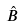Convert formula to latex. <formula><loc_0><loc_0><loc_500><loc_500>\hat { B }</formula> 